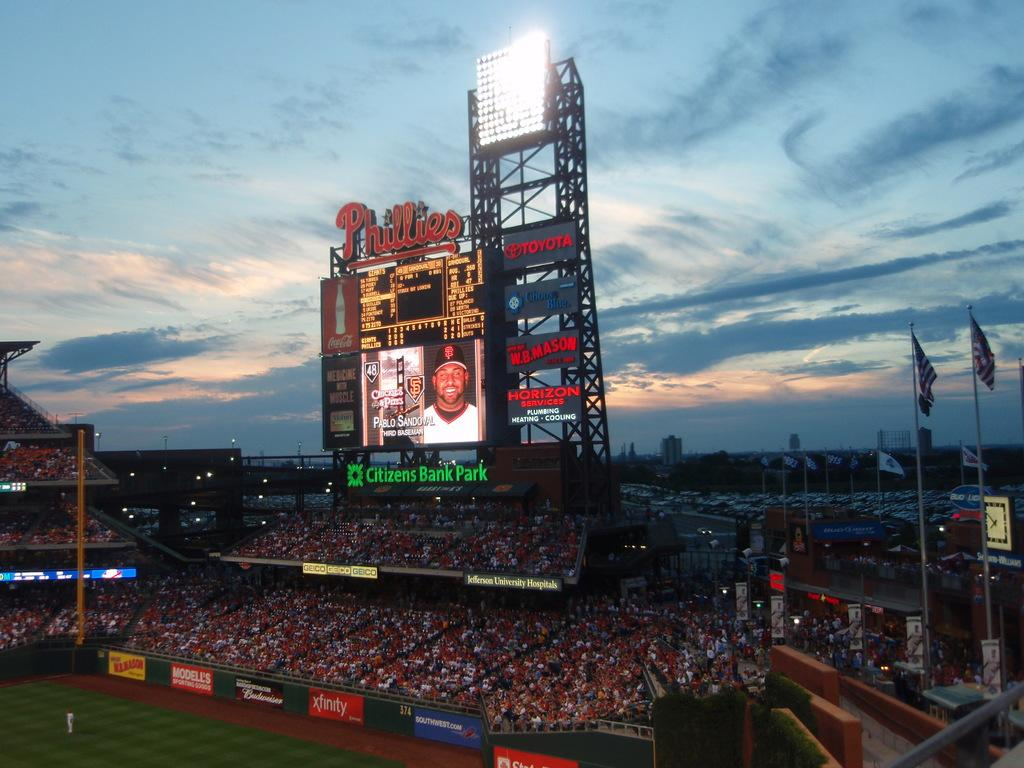Provide a one-sentence caption for the provided image. Citizens Bank Park is a sponsor of the large screen. 